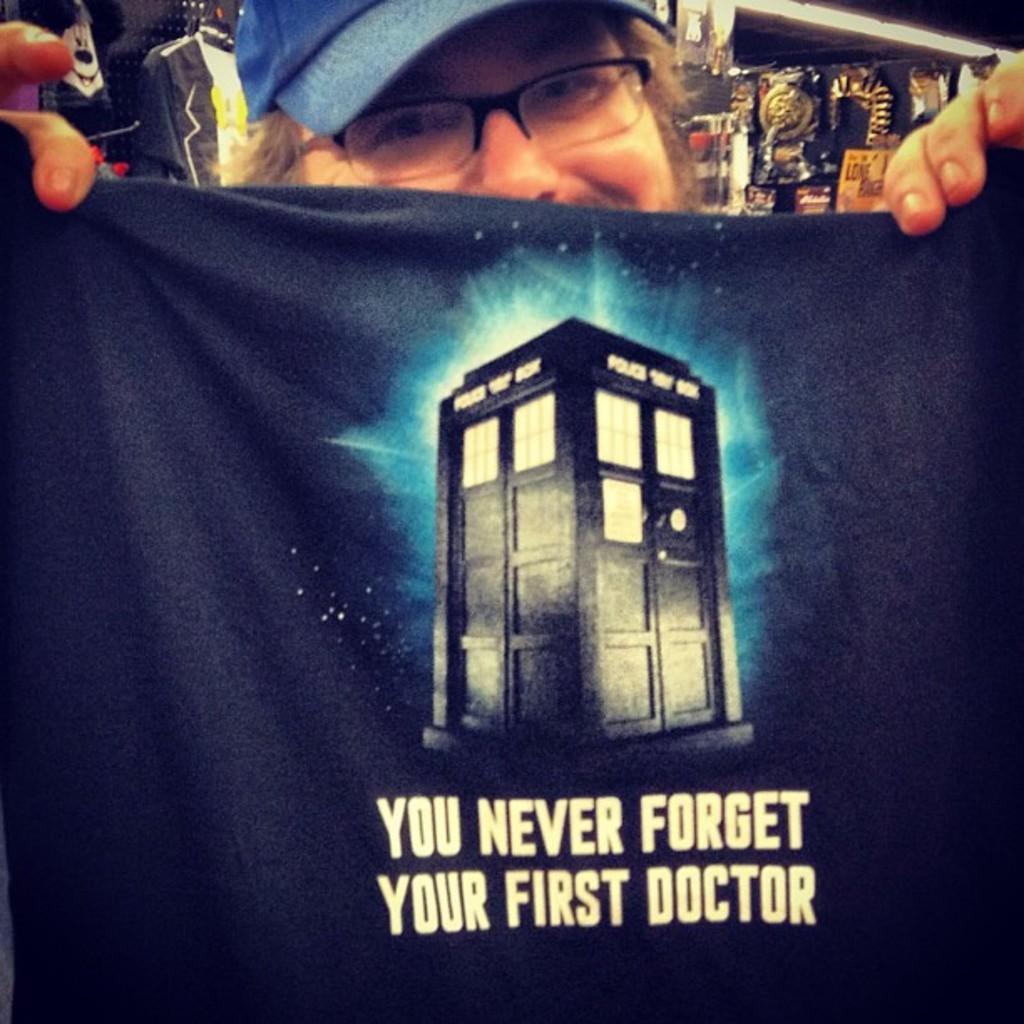In one or two sentences, can you explain what this image depicts? In this image we can see a person wearing spectacles, blue color cap holding a black cloth in his hands on which it is written as you never forget your first doctor and in the background of the image there is shop. 